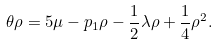<formula> <loc_0><loc_0><loc_500><loc_500>\theta \rho = 5 \mu - p _ { 1 } \rho - \frac { 1 } { 2 } \lambda \rho + \frac { 1 } { 4 } \rho ^ { 2 } .</formula> 